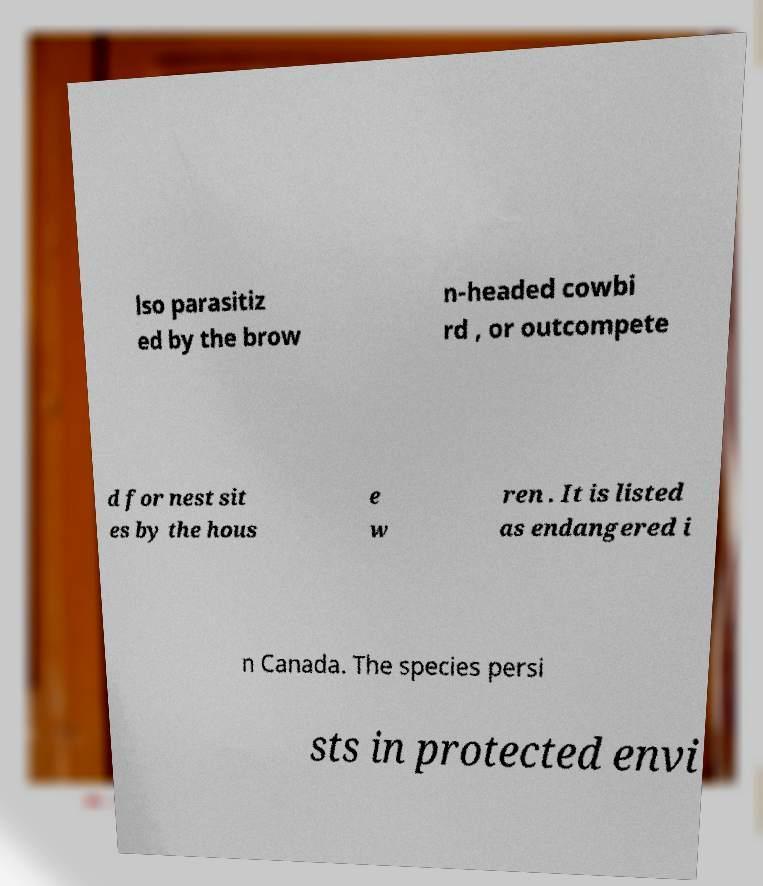Can you read and provide the text displayed in the image?This photo seems to have some interesting text. Can you extract and type it out for me? lso parasitiz ed by the brow n-headed cowbi rd , or outcompete d for nest sit es by the hous e w ren . It is listed as endangered i n Canada. The species persi sts in protected envi 